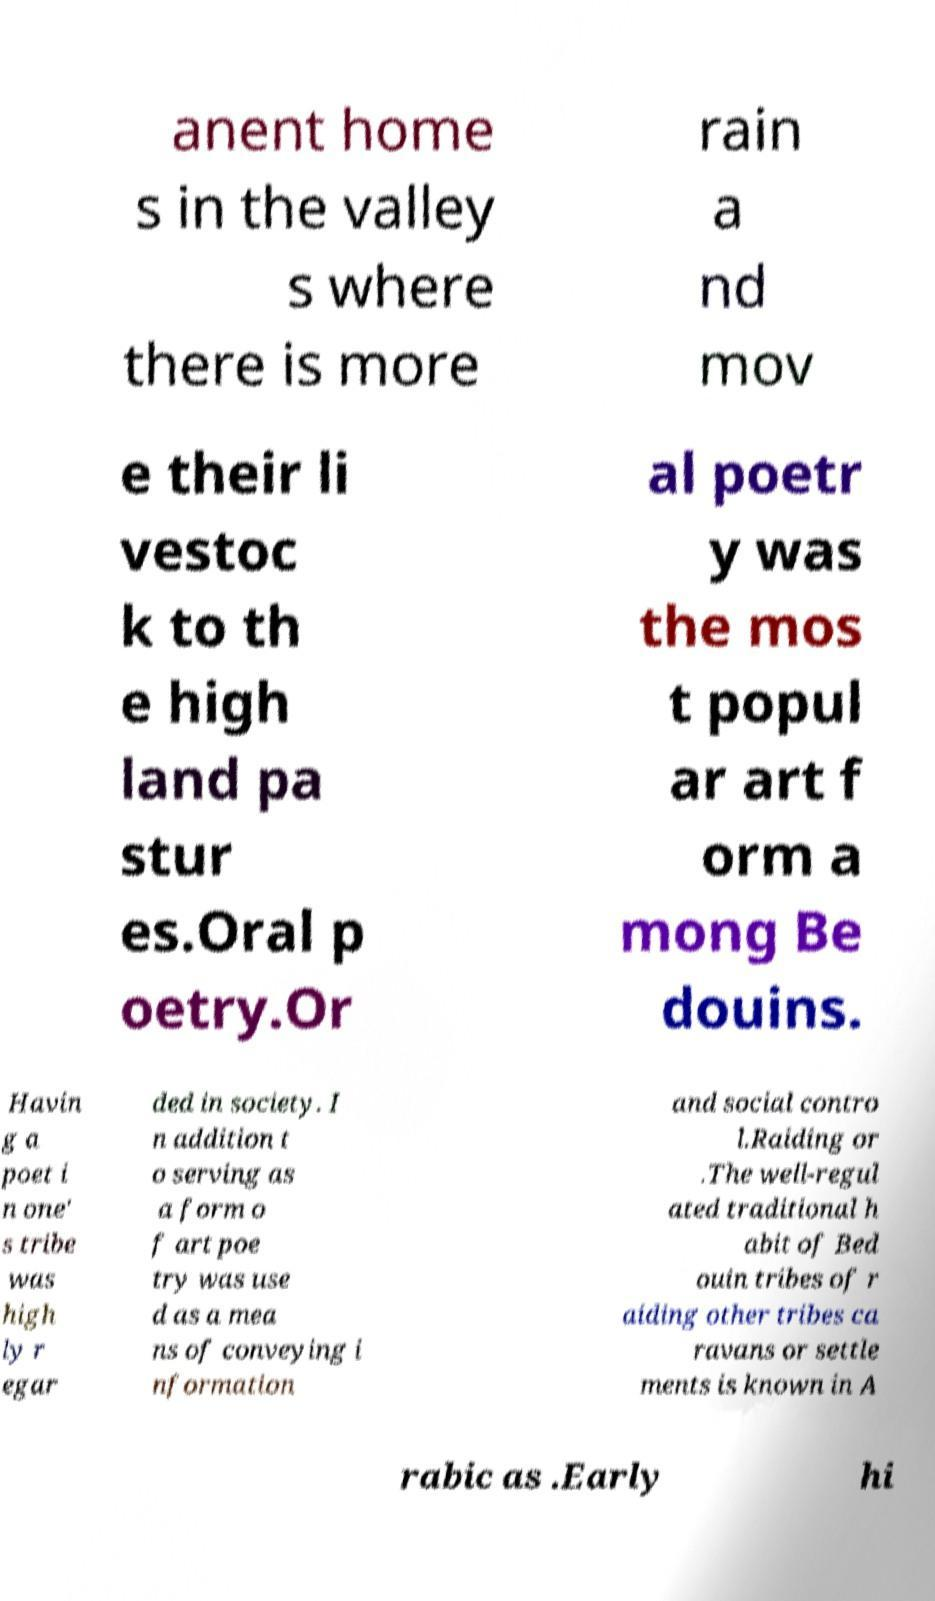Can you accurately transcribe the text from the provided image for me? anent home s in the valley s where there is more rain a nd mov e their li vestoc k to th e high land pa stur es.Oral p oetry.Or al poetr y was the mos t popul ar art f orm a mong Be douins. Havin g a poet i n one' s tribe was high ly r egar ded in society. I n addition t o serving as a form o f art poe try was use d as a mea ns of conveying i nformation and social contro l.Raiding or .The well-regul ated traditional h abit of Bed ouin tribes of r aiding other tribes ca ravans or settle ments is known in A rabic as .Early hi 